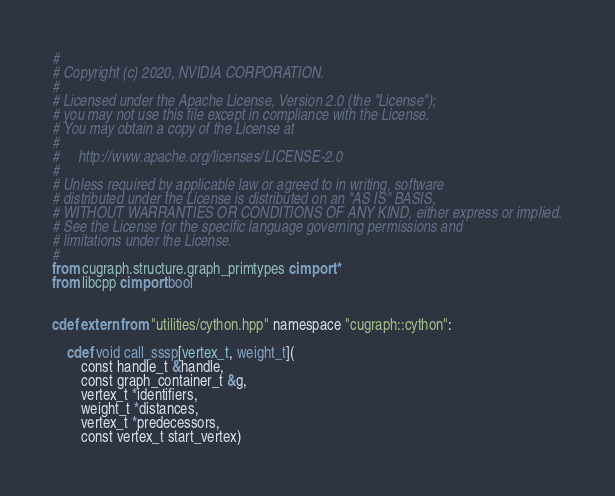<code> <loc_0><loc_0><loc_500><loc_500><_Cython_>#
# Copyright (c) 2020, NVIDIA CORPORATION.
#
# Licensed under the Apache License, Version 2.0 (the "License");
# you may not use this file except in compliance with the License.
# You may obtain a copy of the License at
#
#     http://www.apache.org/licenses/LICENSE-2.0
#
# Unless required by applicable law or agreed to in writing, software
# distributed under the License is distributed on an "AS IS" BASIS,
# WITHOUT WARRANTIES OR CONDITIONS OF ANY KIND, either express or implied.
# See the License for the specific language governing permissions and
# limitations under the License.
#
from cugraph.structure.graph_primtypes cimport *
from libcpp cimport bool


cdef extern from "utilities/cython.hpp" namespace "cugraph::cython":

    cdef void call_sssp[vertex_t, weight_t](
        const handle_t &handle,
        const graph_container_t &g,
        vertex_t *identifiers,
        weight_t *distances,
        vertex_t *predecessors,
        const vertex_t start_vertex)
</code> 